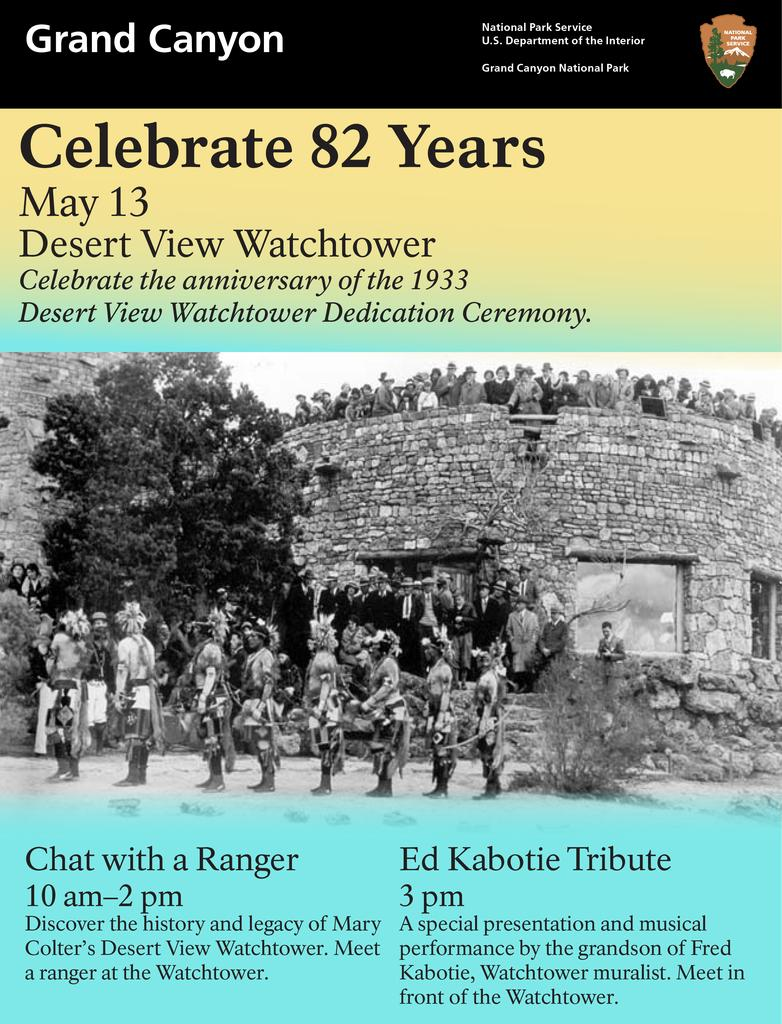<image>
Describe the image concisely. A flyer for a celebration at the Grand Canyon. 